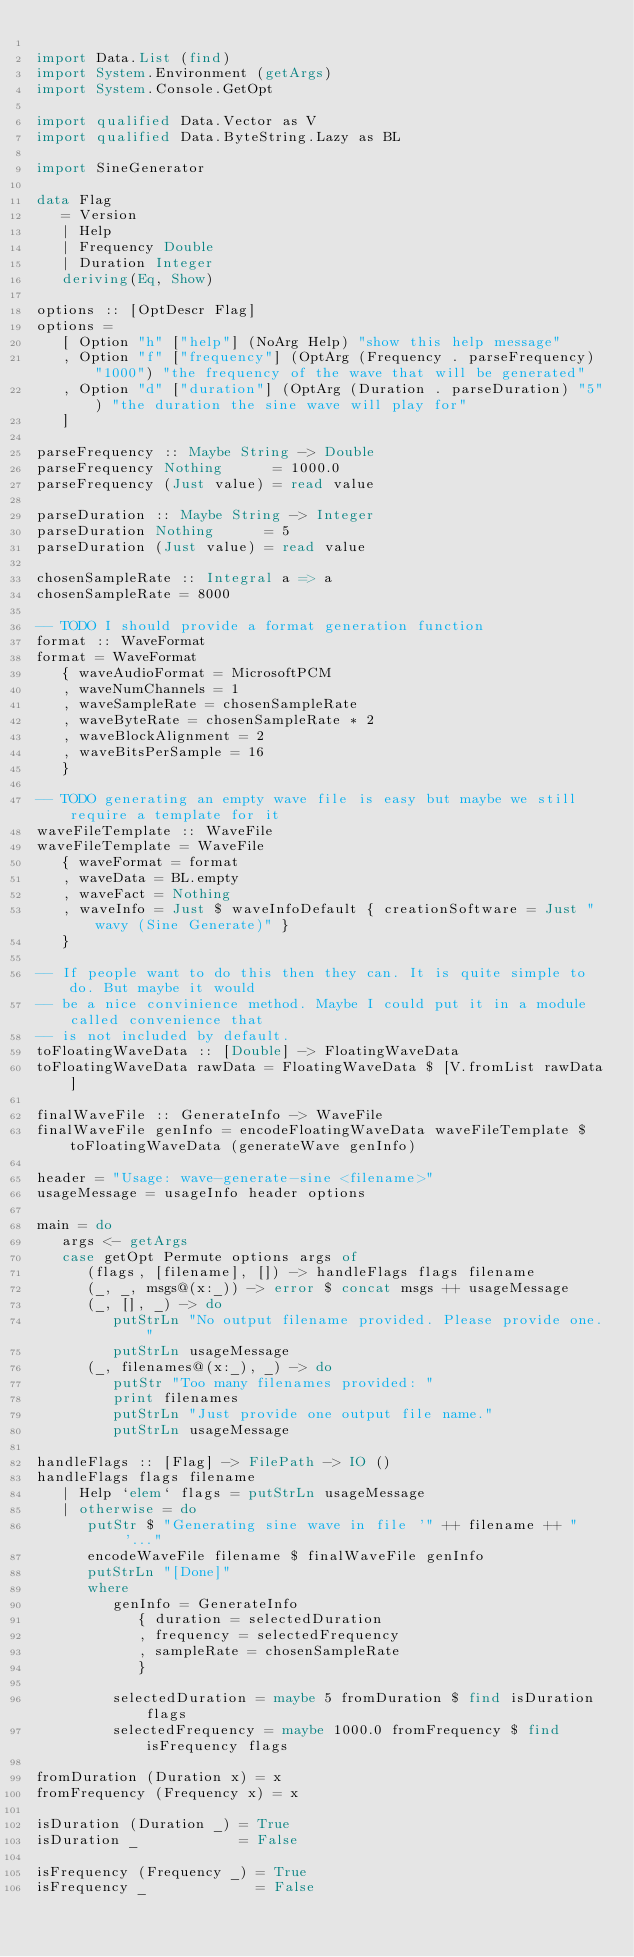<code> <loc_0><loc_0><loc_500><loc_500><_Haskell_>
import Data.List (find)
import System.Environment (getArgs)
import System.Console.GetOpt

import qualified Data.Vector as V
import qualified Data.ByteString.Lazy as BL

import SineGenerator

data Flag 
   = Version 
   | Help 
   | Frequency Double
   | Duration Integer
   deriving(Eq, Show)

options :: [OptDescr Flag]
options = 
   [ Option "h" ["help"] (NoArg Help) "show this help message"
   , Option "f" ["frequency"] (OptArg (Frequency . parseFrequency) "1000") "the frequency of the wave that will be generated"
   , Option "d" ["duration"] (OptArg (Duration . parseDuration) "5") "the duration the sine wave will play for"
   ]

parseFrequency :: Maybe String -> Double
parseFrequency Nothing      = 1000.0
parseFrequency (Just value) = read value

parseDuration :: Maybe String -> Integer
parseDuration Nothing      = 5
parseDuration (Just value) = read value

chosenSampleRate :: Integral a => a
chosenSampleRate = 8000

-- TODO I should provide a format generation function
format :: WaveFormat
format = WaveFormat
   { waveAudioFormat = MicrosoftPCM
   , waveNumChannels = 1
   , waveSampleRate = chosenSampleRate
   , waveByteRate = chosenSampleRate * 2
   , waveBlockAlignment = 2
   , waveBitsPerSample = 16
   }

-- TODO generating an empty wave file is easy but maybe we still require a template for it
waveFileTemplate :: WaveFile
waveFileTemplate = WaveFile
   { waveFormat = format
   , waveData = BL.empty
   , waveFact = Nothing
   , waveInfo = Just $ waveInfoDefault { creationSoftware = Just "wavy (Sine Generate)" }
   }

-- If people want to do this then they can. It is quite simple to do. But maybe it would
-- be a nice convinience method. Maybe I could put it in a module called convenience that
-- is not included by default.
toFloatingWaveData :: [Double] -> FloatingWaveData
toFloatingWaveData rawData = FloatingWaveData $ [V.fromList rawData]

finalWaveFile :: GenerateInfo -> WaveFile
finalWaveFile genInfo = encodeFloatingWaveData waveFileTemplate $ toFloatingWaveData (generateWave genInfo)

header = "Usage: wave-generate-sine <filename>"
usageMessage = usageInfo header options

main = do
   args <- getArgs
   case getOpt Permute options args of
      (flags, [filename], []) -> handleFlags flags filename
      (_, _, msgs@(x:_)) -> error $ concat msgs ++ usageMessage
      (_, [], _) -> do
         putStrLn "No output filename provided. Please provide one."
         putStrLn usageMessage
      (_, filenames@(x:_), _) -> do
         putStr "Too many filenames provided: "
         print filenames
         putStrLn "Just provide one output file name."
         putStrLn usageMessage

handleFlags :: [Flag] -> FilePath -> IO ()
handleFlags flags filename
   | Help `elem` flags = putStrLn usageMessage
   | otherwise = do
      putStr $ "Generating sine wave in file '" ++ filename ++ "'..."
      encodeWaveFile filename $ finalWaveFile genInfo
      putStrLn "[Done]"
      where
         genInfo = GenerateInfo
            { duration = selectedDuration
            , frequency = selectedFrequency
            , sampleRate = chosenSampleRate
            }

         selectedDuration = maybe 5 fromDuration $ find isDuration flags
         selectedFrequency = maybe 1000.0 fromFrequency $ find isFrequency flags

fromDuration (Duration x) = x
fromFrequency (Frequency x) = x

isDuration (Duration _) = True
isDuration _            = False

isFrequency (Frequency _) = True
isFrequency _             = False
</code> 